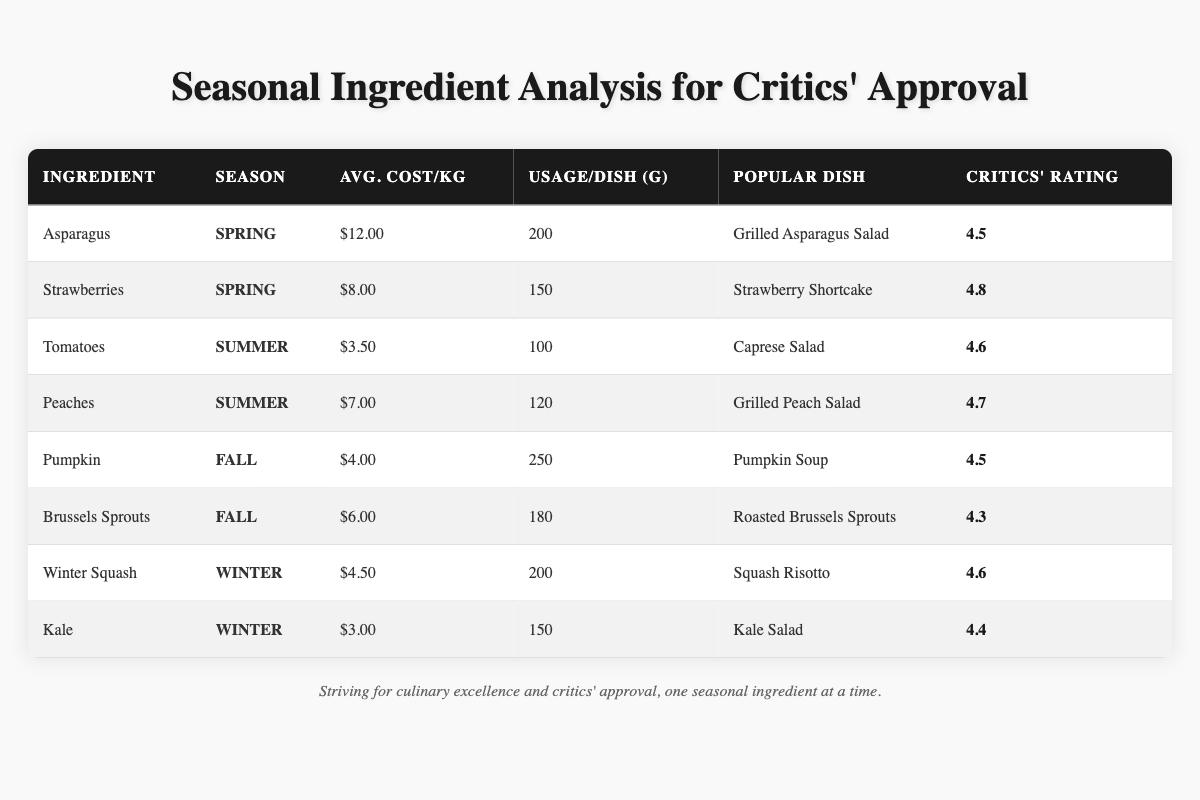What is the average cost per kilogram of strawberries? The table shows that the average cost per kilogram of strawberries is listed directly under the average cost column for that ingredient, which is $8.00.
Answer: $8.00 Which seasonal ingredient has the highest critics' rating? By comparing the critics' ratings listed in the table, strawberries have the highest rating at 4.8, making it the top-rated ingredient.
Answer: Strawberries How much do you use of pumpkin per dish? The usage per dish for pumpkin is provided directly in the table, which indicates it is used at a rate of 250 grams per dish.
Answer: 250 grams What is the total usage in grams for all dishes containing tomatoes? From the table, tomatoes are reported to be used at 100 grams per dish, and there is only one entry for tomatoes; thus, the total usage is 100 grams.
Answer: 100 grams Are winter squash and kale both used in winter dishes? The seasonal column for winter squash and kale confirms that they are both used in winter, so the statement is true.
Answer: Yes What is the average critics' rating for dishes made with fall seasonal ingredients? The critics' ratings for fall ingredients (pumpkin, 4.5; Brussels sprouts, 4.3) are averaged: (4.5 + 4.3) / 2 = 4.4. Hence, the average rating is 4.4.
Answer: 4.4 Is the average cost of summer ingredients lower than that of spring ingredients? The average cost for summer ingredients (tomatoes: $3.50, peaches: $7.00) is ($3.50 + $7.00) / 2 = $5.25. For spring ingredients (asparagus: $12.00, strawberries: $8.00), it is ($12.00 + $8.00) / 2 = $10.00. Since $5.25 is less than $10.00, the average cost of summer ingredients is lower.
Answer: Yes How much more does asparagus cost per kilogram compared to tomatoes? The average cost of asparagus ($12.00) minus the average cost of tomatoes ($3.50) gives a difference of $8.50. Thus, asparagus costs $8.50 more than tomatoes per kilogram.
Answer: $8.50 Which dish has the lowest critics' rating among the seasonal ingredients? By examining the ratings, the dish "Roasted Brussels Sprouts" has the lowest rating at 4.3, making it the one with the lowest critics' approval.
Answer: Roasted Brussels Sprouts What is the cost of ingredients used for a single dish of grilled peach salad? To find the cost, use the average cost of peaches ($7.00) and the amount used per dish (120 grams), so the cost for one dish is ($7.00 / 1000) * 120 = $0.84.
Answer: $0.84 